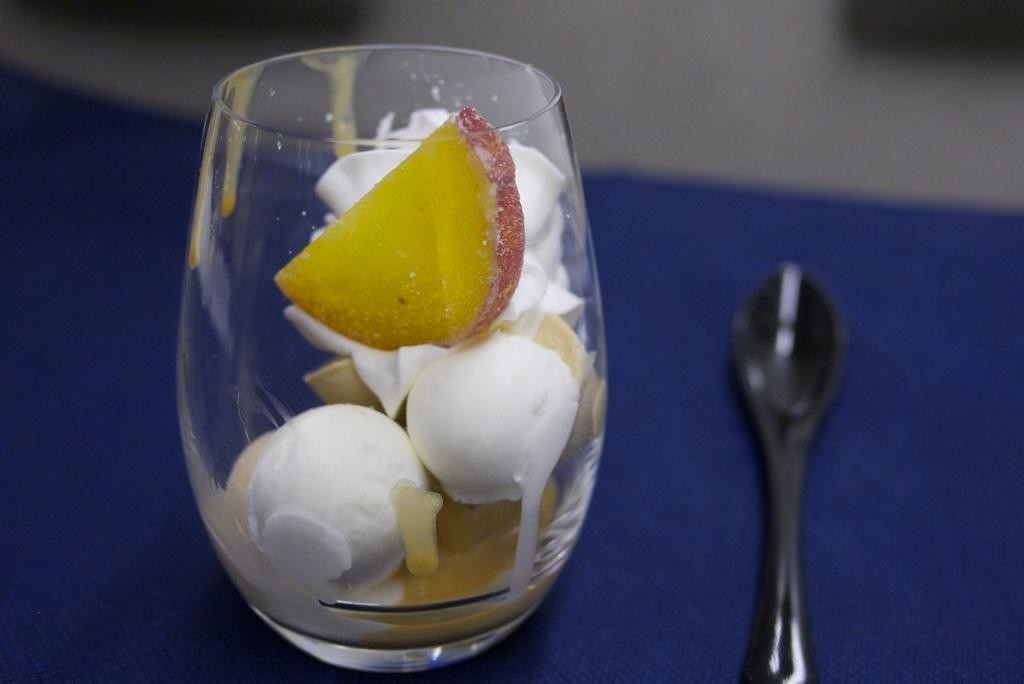What is inside the glass in the image? There are ice cream scoops, apple slices, and other fruit slices in the glass. What utensil is visible in the image? There is a spoon on the table. Where are the glass and spoon located? The glass and spoon are on a table. What songs are being sung by the tooth in the church in the image? There is no tooth or church present in the image; it features a glass with ice cream scoops, apple slices, and other fruit slices, along with a spoon on a table. 